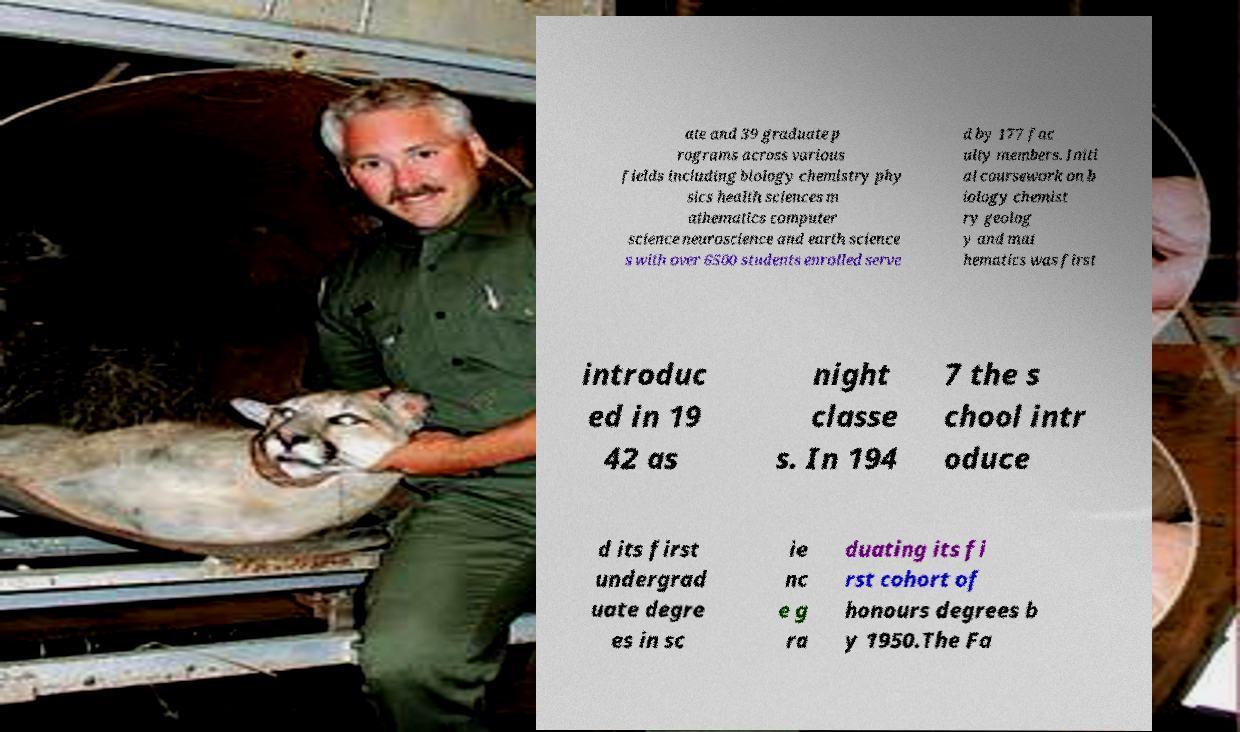What messages or text are displayed in this image? I need them in a readable, typed format. ate and 39 graduate p rograms across various fields including biology chemistry phy sics health sciences m athematics computer science neuroscience and earth science s with over 6500 students enrolled serve d by 177 fac ulty members. Initi al coursework on b iology chemist ry geolog y and mat hematics was first introduc ed in 19 42 as night classe s. In 194 7 the s chool intr oduce d its first undergrad uate degre es in sc ie nc e g ra duating its fi rst cohort of honours degrees b y 1950.The Fa 